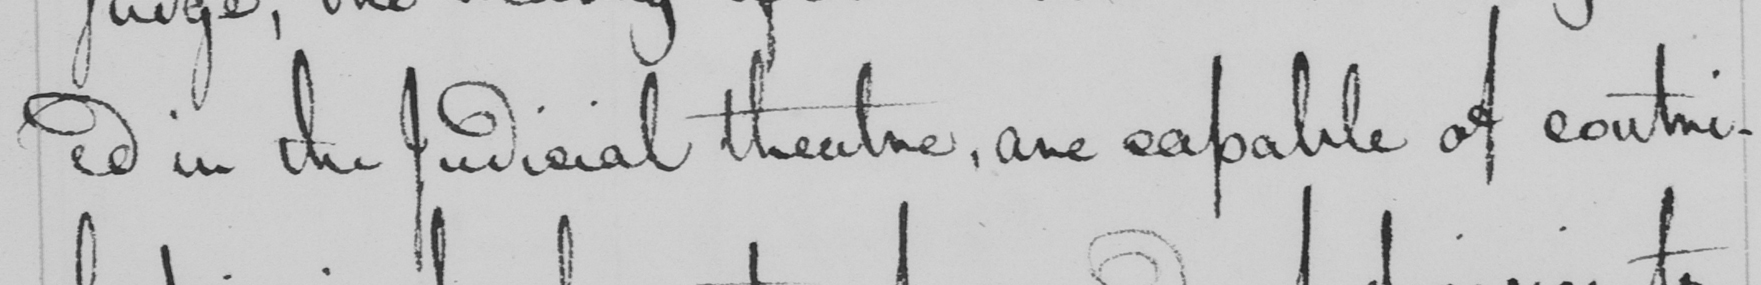Can you read and transcribe this handwriting? ed in the Judicial theatre , are capable of contri- 